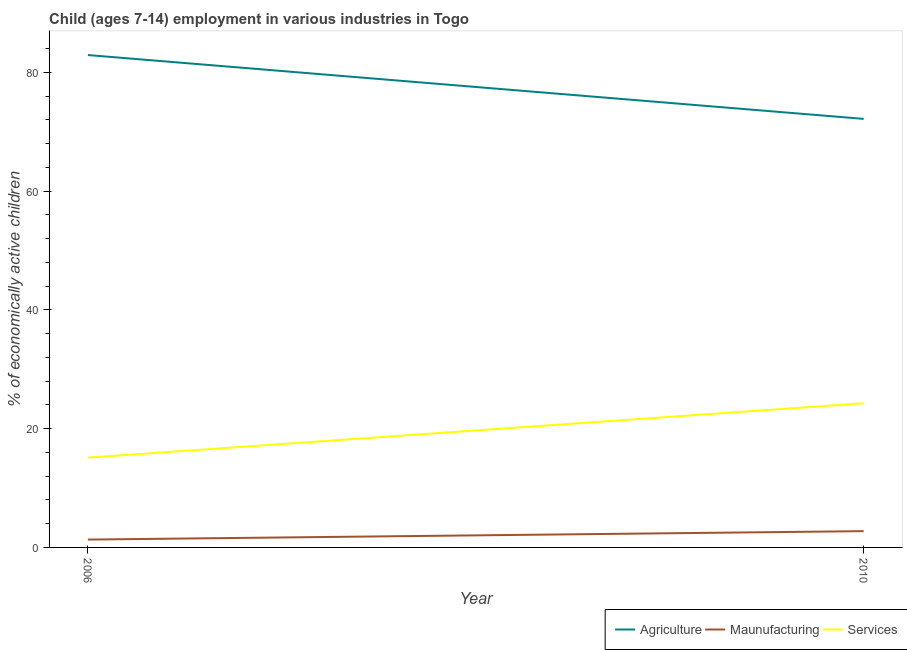Does the line corresponding to percentage of economically active children in manufacturing intersect with the line corresponding to percentage of economically active children in agriculture?
Provide a succinct answer. No. Is the number of lines equal to the number of legend labels?
Offer a terse response. Yes. What is the percentage of economically active children in agriculture in 2006?
Your response must be concise. 82.91. Across all years, what is the maximum percentage of economically active children in agriculture?
Provide a short and direct response. 82.91. Across all years, what is the minimum percentage of economically active children in services?
Your answer should be very brief. 15.12. In which year was the percentage of economically active children in agriculture maximum?
Your answer should be very brief. 2006. In which year was the percentage of economically active children in manufacturing minimum?
Provide a succinct answer. 2006. What is the total percentage of economically active children in manufacturing in the graph?
Ensure brevity in your answer.  4.06. What is the difference between the percentage of economically active children in manufacturing in 2006 and that in 2010?
Provide a short and direct response. -1.42. What is the difference between the percentage of economically active children in manufacturing in 2010 and the percentage of economically active children in services in 2006?
Your response must be concise. -12.38. What is the average percentage of economically active children in manufacturing per year?
Provide a short and direct response. 2.03. In the year 2010, what is the difference between the percentage of economically active children in manufacturing and percentage of economically active children in services?
Offer a very short reply. -21.54. In how many years, is the percentage of economically active children in manufacturing greater than 16 %?
Your answer should be compact. 0. What is the ratio of the percentage of economically active children in services in 2006 to that in 2010?
Offer a very short reply. 0.62. Is it the case that in every year, the sum of the percentage of economically active children in agriculture and percentage of economically active children in manufacturing is greater than the percentage of economically active children in services?
Your response must be concise. Yes. Is the percentage of economically active children in services strictly less than the percentage of economically active children in agriculture over the years?
Your answer should be compact. Yes. How many lines are there?
Make the answer very short. 3. Does the graph contain any zero values?
Your answer should be very brief. No. How are the legend labels stacked?
Provide a short and direct response. Horizontal. What is the title of the graph?
Keep it short and to the point. Child (ages 7-14) employment in various industries in Togo. Does "Labor Tax" appear as one of the legend labels in the graph?
Provide a short and direct response. No. What is the label or title of the X-axis?
Provide a succinct answer. Year. What is the label or title of the Y-axis?
Ensure brevity in your answer.  % of economically active children. What is the % of economically active children of Agriculture in 2006?
Give a very brief answer. 82.91. What is the % of economically active children in Maunufacturing in 2006?
Provide a short and direct response. 1.32. What is the % of economically active children of Services in 2006?
Provide a succinct answer. 15.12. What is the % of economically active children of Agriculture in 2010?
Your response must be concise. 72.16. What is the % of economically active children of Maunufacturing in 2010?
Make the answer very short. 2.74. What is the % of economically active children in Services in 2010?
Your response must be concise. 24.28. Across all years, what is the maximum % of economically active children in Agriculture?
Keep it short and to the point. 82.91. Across all years, what is the maximum % of economically active children in Maunufacturing?
Your answer should be compact. 2.74. Across all years, what is the maximum % of economically active children in Services?
Your answer should be compact. 24.28. Across all years, what is the minimum % of economically active children of Agriculture?
Provide a succinct answer. 72.16. Across all years, what is the minimum % of economically active children of Maunufacturing?
Keep it short and to the point. 1.32. Across all years, what is the minimum % of economically active children in Services?
Keep it short and to the point. 15.12. What is the total % of economically active children in Agriculture in the graph?
Offer a very short reply. 155.07. What is the total % of economically active children in Maunufacturing in the graph?
Offer a terse response. 4.06. What is the total % of economically active children in Services in the graph?
Provide a short and direct response. 39.4. What is the difference between the % of economically active children of Agriculture in 2006 and that in 2010?
Make the answer very short. 10.75. What is the difference between the % of economically active children in Maunufacturing in 2006 and that in 2010?
Keep it short and to the point. -1.42. What is the difference between the % of economically active children of Services in 2006 and that in 2010?
Your response must be concise. -9.16. What is the difference between the % of economically active children in Agriculture in 2006 and the % of economically active children in Maunufacturing in 2010?
Offer a terse response. 80.17. What is the difference between the % of economically active children of Agriculture in 2006 and the % of economically active children of Services in 2010?
Your answer should be compact. 58.63. What is the difference between the % of economically active children in Maunufacturing in 2006 and the % of economically active children in Services in 2010?
Provide a succinct answer. -22.96. What is the average % of economically active children of Agriculture per year?
Your answer should be very brief. 77.53. What is the average % of economically active children in Maunufacturing per year?
Ensure brevity in your answer.  2.03. What is the average % of economically active children of Services per year?
Keep it short and to the point. 19.7. In the year 2006, what is the difference between the % of economically active children in Agriculture and % of economically active children in Maunufacturing?
Ensure brevity in your answer.  81.59. In the year 2006, what is the difference between the % of economically active children of Agriculture and % of economically active children of Services?
Your answer should be compact. 67.79. In the year 2006, what is the difference between the % of economically active children of Maunufacturing and % of economically active children of Services?
Make the answer very short. -13.8. In the year 2010, what is the difference between the % of economically active children of Agriculture and % of economically active children of Maunufacturing?
Your answer should be very brief. 69.42. In the year 2010, what is the difference between the % of economically active children in Agriculture and % of economically active children in Services?
Your answer should be compact. 47.88. In the year 2010, what is the difference between the % of economically active children in Maunufacturing and % of economically active children in Services?
Provide a succinct answer. -21.54. What is the ratio of the % of economically active children in Agriculture in 2006 to that in 2010?
Your answer should be compact. 1.15. What is the ratio of the % of economically active children of Maunufacturing in 2006 to that in 2010?
Make the answer very short. 0.48. What is the ratio of the % of economically active children of Services in 2006 to that in 2010?
Your response must be concise. 0.62. What is the difference between the highest and the second highest % of economically active children in Agriculture?
Provide a succinct answer. 10.75. What is the difference between the highest and the second highest % of economically active children of Maunufacturing?
Keep it short and to the point. 1.42. What is the difference between the highest and the second highest % of economically active children of Services?
Keep it short and to the point. 9.16. What is the difference between the highest and the lowest % of economically active children in Agriculture?
Give a very brief answer. 10.75. What is the difference between the highest and the lowest % of economically active children of Maunufacturing?
Make the answer very short. 1.42. What is the difference between the highest and the lowest % of economically active children of Services?
Your answer should be compact. 9.16. 